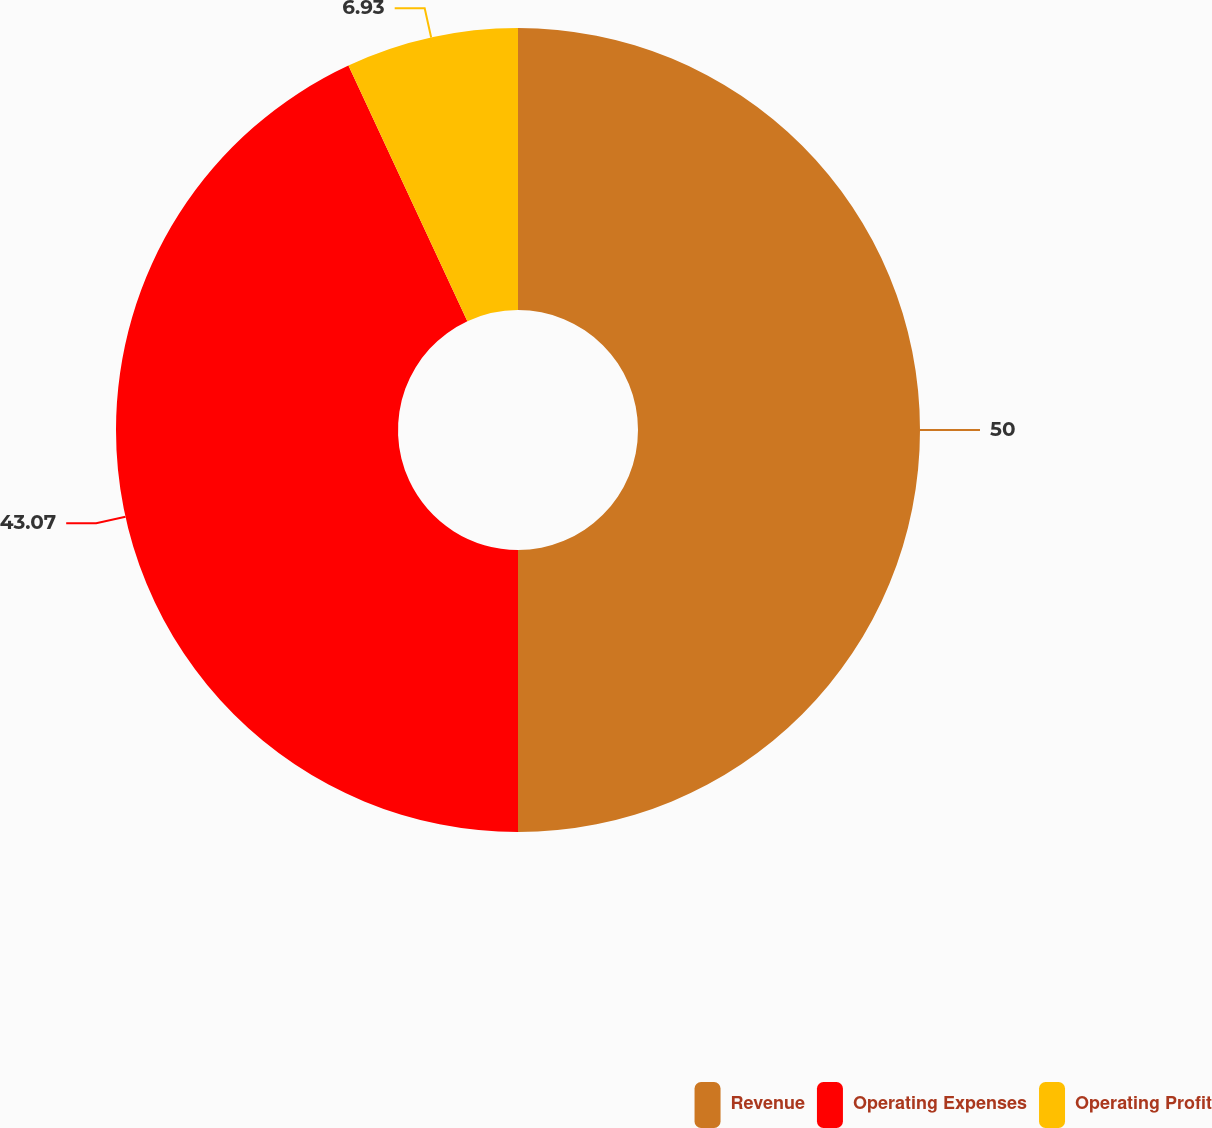Convert chart to OTSL. <chart><loc_0><loc_0><loc_500><loc_500><pie_chart><fcel>Revenue<fcel>Operating Expenses<fcel>Operating Profit<nl><fcel>50.0%<fcel>43.07%<fcel>6.93%<nl></chart> 